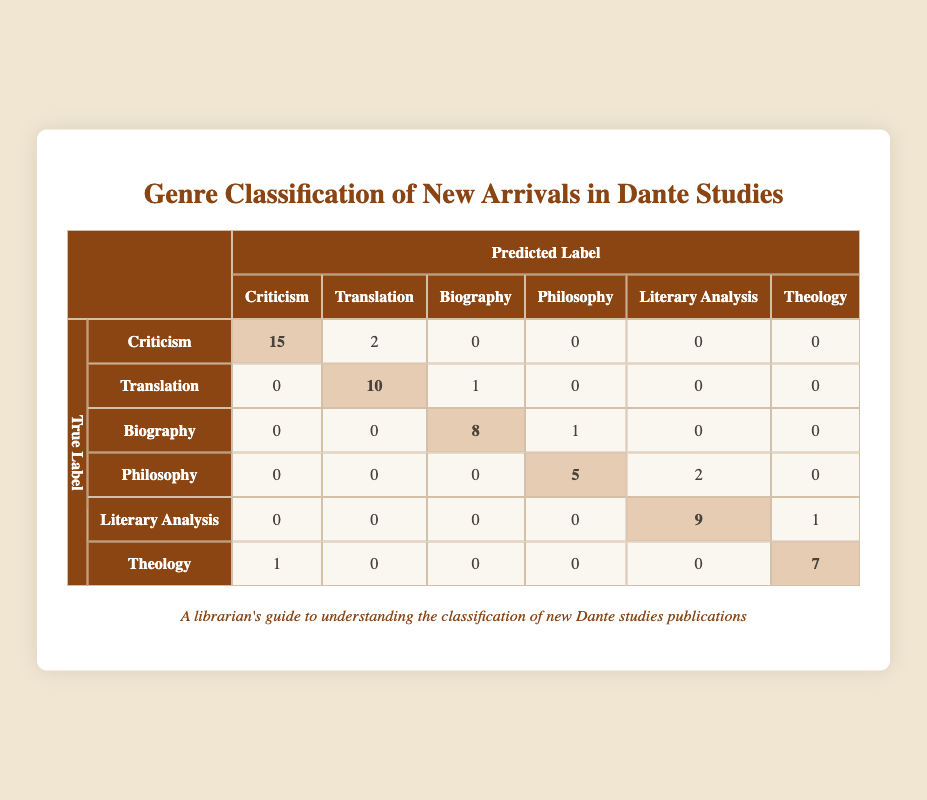What is the predicted count for True Label "Criticism" that was classified as "Translation"? In the table, under the row for the True Label "Criticism", the count for the predicted label "Translation" is listed. By checking this specific cell, we see the count is 2.
Answer: 2 How many books were classified correctly under the label "Theology"? To find the count for "Theology" that was predicted as "Theology", we look at the row for "Theology" and find the diagonal value, which is 7. This indicates that 7 books were correctly classified as "Theology".
Answer: 7 What genre had the highest number of misclassifications? By examining the off-diagonal counts for each genre, the misclassifications can be summed. "Criticism" had 2 misclassified as "Translation", "Translation" had 1 misclassified as "Biography", "Biography" had 1 as "Philosophy", "Philosophy" had 2 as "Literary Analysis", "Literary Analysis" had 1 as "Theology", and "Theology" had 1 as "Criticism". The highest is 2 for "Criticism" misclassified as "Translation" and "Philosophy" misclassified as "Literary Analysis".
Answer: Criticism and Philosophy What is the total number of books predicted as "Literary Analysis"? To find this, we look at the entire "Literary Analysis" column. The counts for the predicted "Literary Analysis" are: 0 (Criticism) + 0 (Translation) + 0 (Biography) + 2 (Philosophy) + 9 (Literary Analysis) + 1 (Theology) which totals to 12.
Answer: 12 Did any books labeled as "Biography" get predicted as "Criticism"? By examining the row for "Biography", we see the count under the "Criticism" column is 0. This indicates that no books labeled as "Biography" were predicted as "Criticism".
Answer: No What is the total number of books predicted as "Philosophy"? For the "Philosophy" column, we sum the counts: 0 (Criticism) + 0 (Translation) + 1 (Biography) + 5 (Philosophy) + 0 (Literary Analysis) + 0 (Theology) which results in 6.
Answer: 6 Which genre has the second highest count of correct predictions? Looking at the diagonal values, "Translation" has 10, "Biography" has 8, and "Theology" has 7. The second highest correct predictions is thus "Biography" with 8.
Answer: Biography What is the average number of misclassified books across all genres? To calculate the average misclassified, we take the sum of all misclassifications: 2 (Criticism) + 1 (Translation) + 1 (Biography) + 2 (Philosophy) + 1 (Literary Analysis) + 1 (Theology) = 8. Then, dividing by the number of genres (6), we get 8/6 ≈ 1.33.
Answer: 1.33 